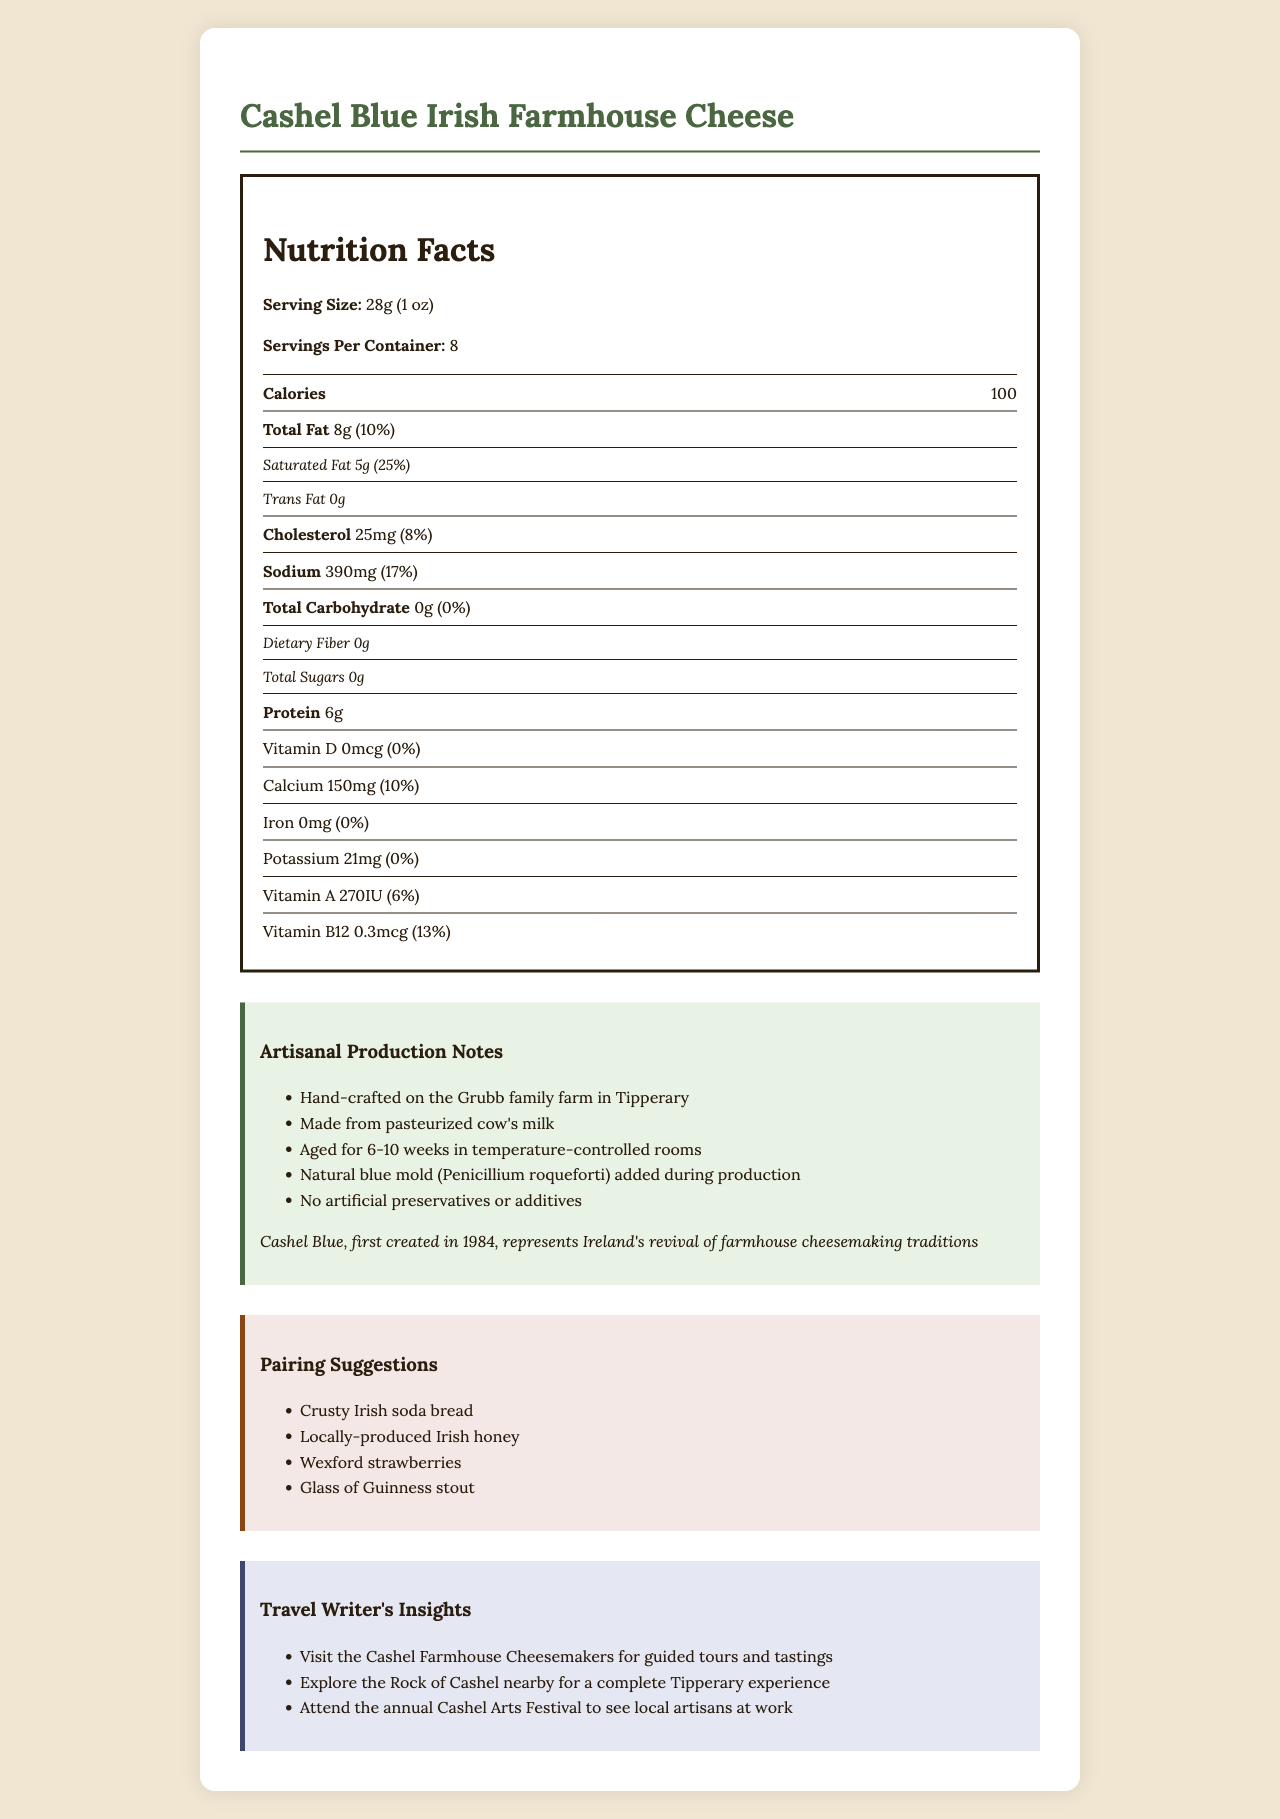what is the serving size of Cashel Blue Irish Farmhouse Cheese? The serving size is clearly provided in the Nutrition Facts section under "Serving Size: 28g (1 oz)".
Answer: 28g (1 oz) how many calories are in one serving? The Nutrition Facts section lists the calories per serving as 100.
Answer: 100 what is the percentage daily value of saturated fat per serving? The Nutrition Facts table shows the saturated fat amount as 5g and the daily value as 25%.
Answer: 25% how much sodium does one serving contain? The Nutrition Facts section indicates the sodium content to be 390mg per serving.
Answer: 390mg what is the amount of Vitamin B12 in one serving? The Nutrition Facts section lists Vitamin B12 as having an amount of 0.3mcg.
Answer: 0.3mcg which one of the following is a pairing suggestion for Cashel Blue Irish Farmhouse Cheese? A. French baguette B. Italian salami C. Tipperary strawberries D. Wexford strawberries The Pairing Suggestions section lists Wexford strawberries as one of the pairing options.
Answer: D. Wexford strawberries where is Cashel Blue Irish Farmhouse Cheese handcrafted? A. Galway B. Tipperary C. Cork D. Dublin The Artisanal Production Notes indicate that the cheese is handcrafted on the Grubb family farm in Tipperary.
Answer: B. Tipperary does Cashel Blue Irish Farmhouse Cheese contain any artificial preservatives or additives? According to the Artisanal Production Notes, no artificial preservatives or additives are used in the cheese.
Answer: No is there dietary fiber in Cashel Blue Irish Farmhouse Cheese? The Nutrition Facts section lists the dietary fiber content as 0g.
Answer: No summarize the main elements of the document The document covers the nutritional content, artisan production details, historical context, and pairing suggestions for Cashel Blue Irish Farmhouse Cheese. It emphasizes the cheese’s artisanal nature, its roots in Tipperary, and travel recommendations for visitors.
Answer: The document provides detailed information about Cashel Blue Irish Farmhouse Cheese, including its nutritional facts, artisanal production methods, historical significance, and pairing suggestions. It highlights the cheese's handcrafted nature on the Grubb family farm in Tipperary, its natural blue mold addition, and lack of artificial preservatives. The document also offers travel insights for visiting the farm and local attractions. what is the total carbohydrate content per serving? The Nutrition Facts section shows that the total carbohydrate content is 0g per serving.
Answer: 0g what is one of the artisan production methods mentioned? The Artisanal Production Notes section includes the information that the cheese is aged for 6-10 weeks in temperature-controlled rooms.
Answer: Aged for 6-10 weeks in temperature-controlled rooms what kind of bread is suggested to pair with the cheese? One of the Pairing Suggestions listed is crusty Irish soda bread.
Answer: Crusty Irish soda bread can you determine how long Cashel Blue has been produced by reading the document? The document states that Cashel Blue was first created in 1984, which indicates it has been produced for around 39 years.
Answer: Yes how many servings are there in one container? The Nutrition Facts section lists the number of servings per container as 8.
Answer: 8 which of the following travel insights is associated with Cashel Blue Irish Farmhouse Cheese? A. Visit the Cashel Farmhouse Cheesemakers for guided tours and tastings B. Explore the Cliffs of Moher C. Visit the Guinness Storehouse D. Tour the Dublin Zoo The Travel Writer's Insights section includes a suggestion to visit the Cashel Farmhouse Cheesemakers for guided tours and tastings.
Answer: A. Visit the Cashel Farmhouse Cheesemakers for guided tours and tastings how much calcium is present in one serving? The Nutrition Facts section indicates that one serving contains 150mg of calcium.
Answer: 150mg describe the historical significance of Cashel Blue Irish Farmhouse Cheese The historical significance is provided in the Artisanal Production Notes, stating that Cashel Blue is part of Ireland's revival of farmhouse cheesemaking.
Answer: Cashel Blue, first created in 1984, represents Ireland's revival of farmhouse cheesemaking traditions how much cholesterol is in one serving? The Nutrition Facts section shows the cholesterol content as 25mg per serving.
Answer: 25mg 